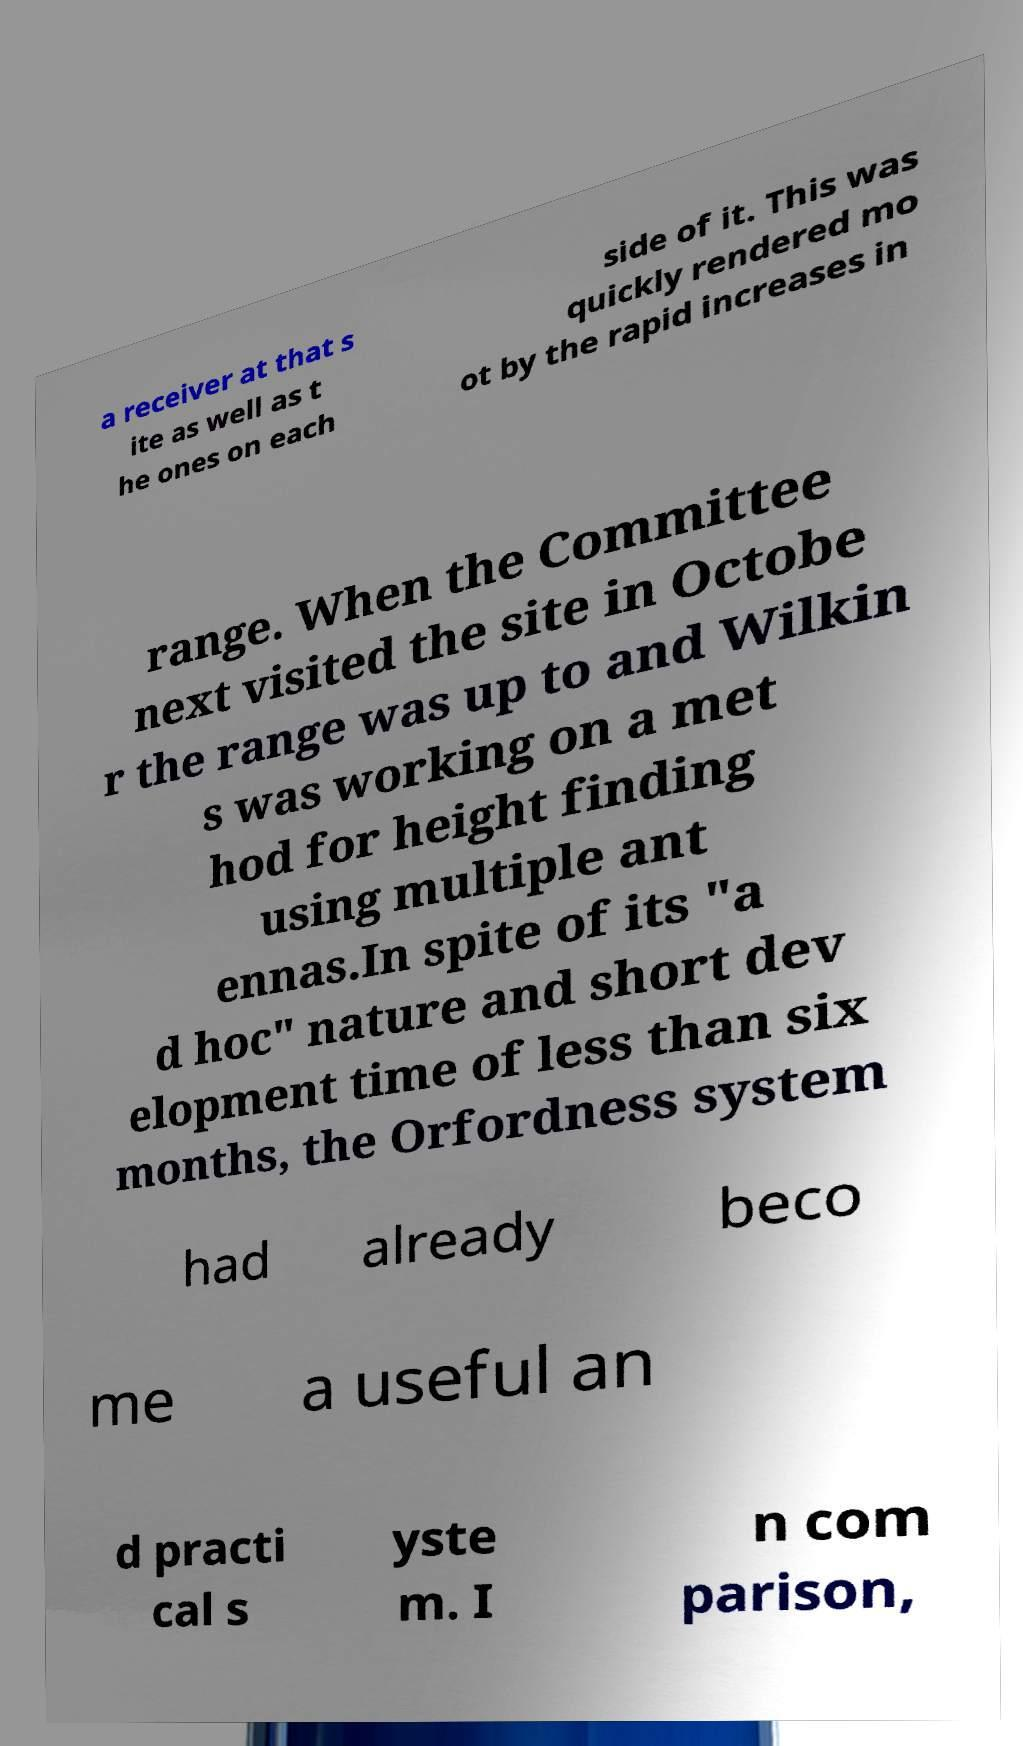Could you extract and type out the text from this image? a receiver at that s ite as well as t he ones on each side of it. This was quickly rendered mo ot by the rapid increases in range. When the Committee next visited the site in Octobe r the range was up to and Wilkin s was working on a met hod for height finding using multiple ant ennas.In spite of its "a d hoc" nature and short dev elopment time of less than six months, the Orfordness system had already beco me a useful an d practi cal s yste m. I n com parison, 